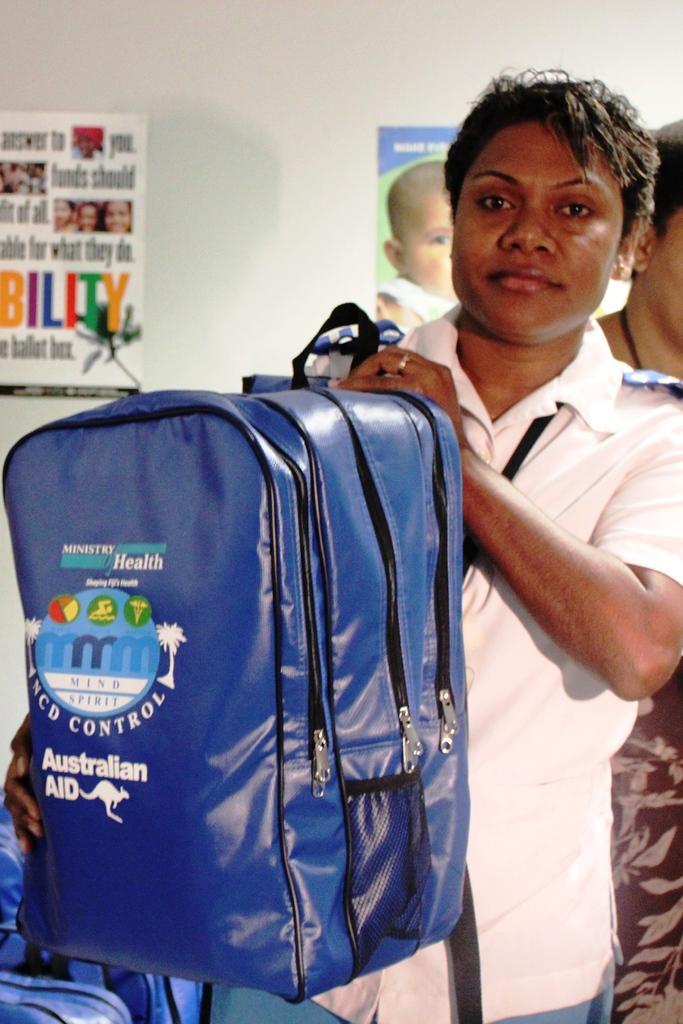Can you describe this image briefly? This is the picture of a room. In this image there is a person standing and holding the bag, at the back there is an another person standing. At the bottom there are bags. At the back there are frames on the wall. 